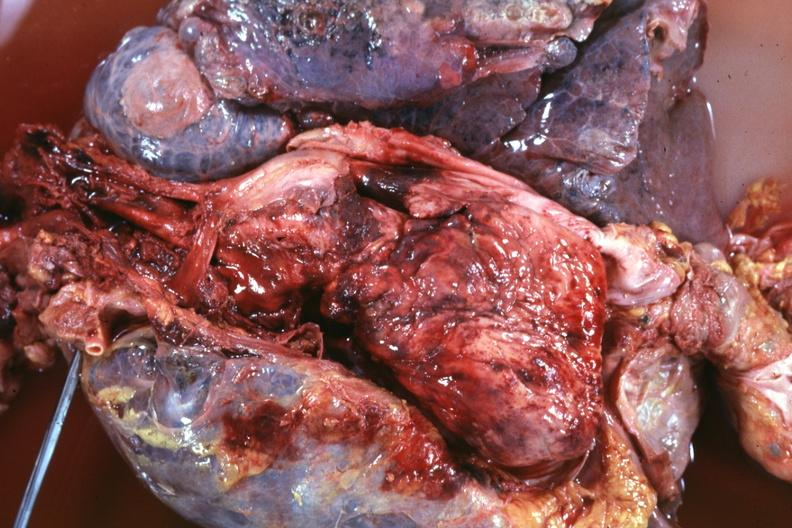s malignant thymoma present?
Answer the question using a single word or phrase. Yes 